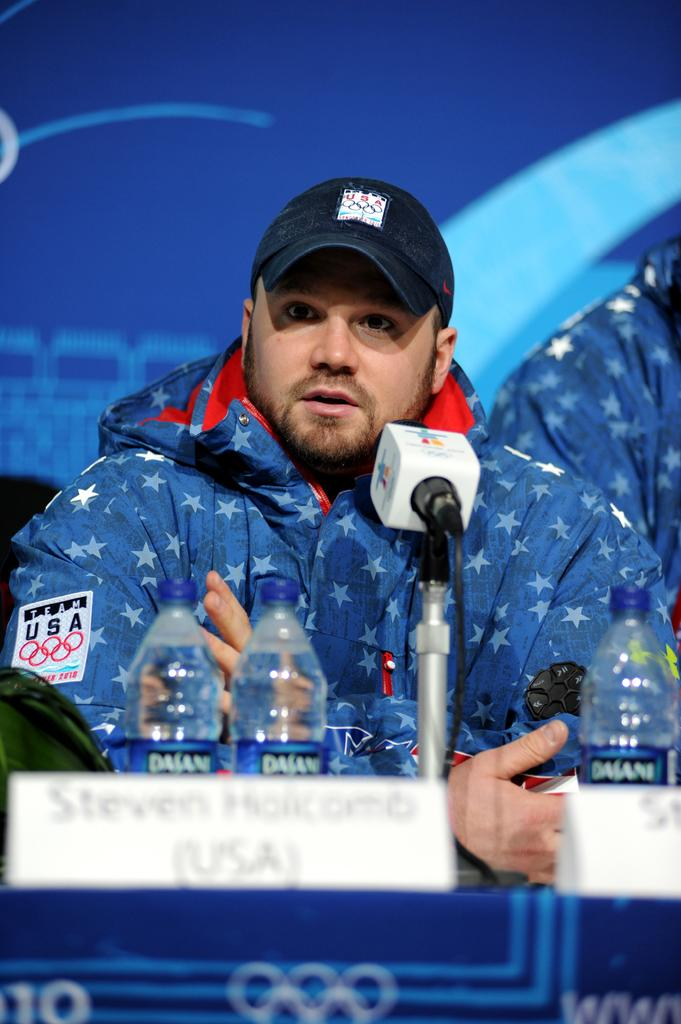What is the man in the image doing? The man is seated and speaking in the image. How is the man able to amplify his voice in the image? The man is using a microphone to speak in the image. What objects can be seen on the table in the image? There are bottles on the table in the image. What type of drug is the stranger offering to the man in the image? There is no stranger present in the image, and no drug is mentioned or visible. 